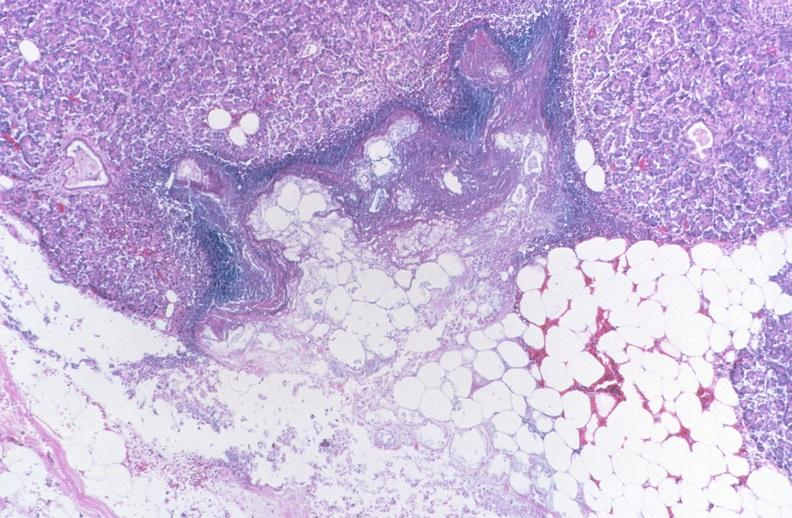where is this?
Answer the question using a single word or phrase. Pancreas 